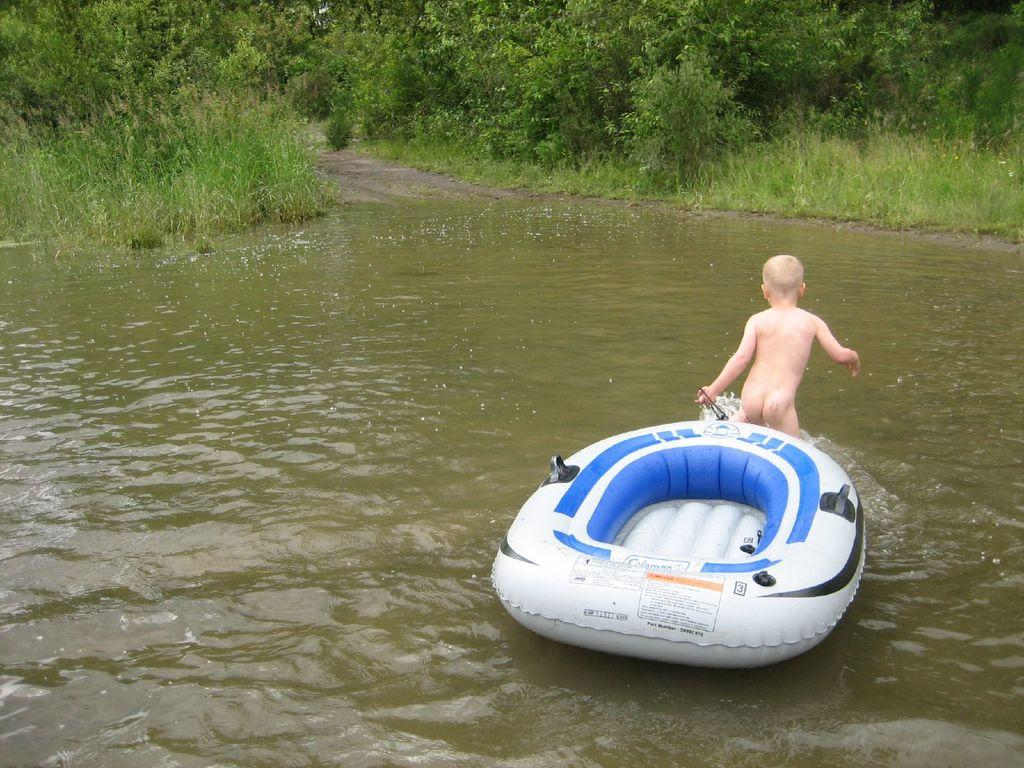What is the main subject of the image? There is a kid in the image. What is located above the water in the image? There is a boat above the water in the image. What type of vegetation can be seen in the background of the image? There are trees in the background of the image. What type of ground surface is visible in the background of the image? There is grass visible in the background of the image. What type of porter is carrying the baby in the image? There is no porter or baby present in the image. 